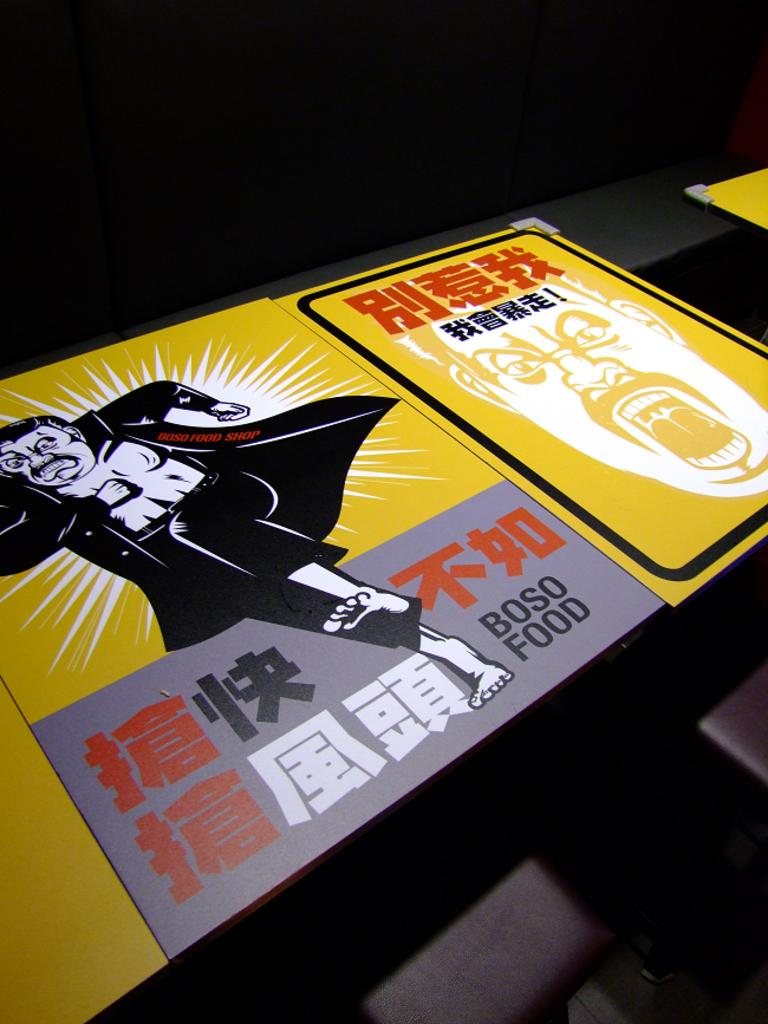<image>
Summarize the visual content of the image. A yellow purple and black box with a man in all black wearing a cape, the box states Boso food. 